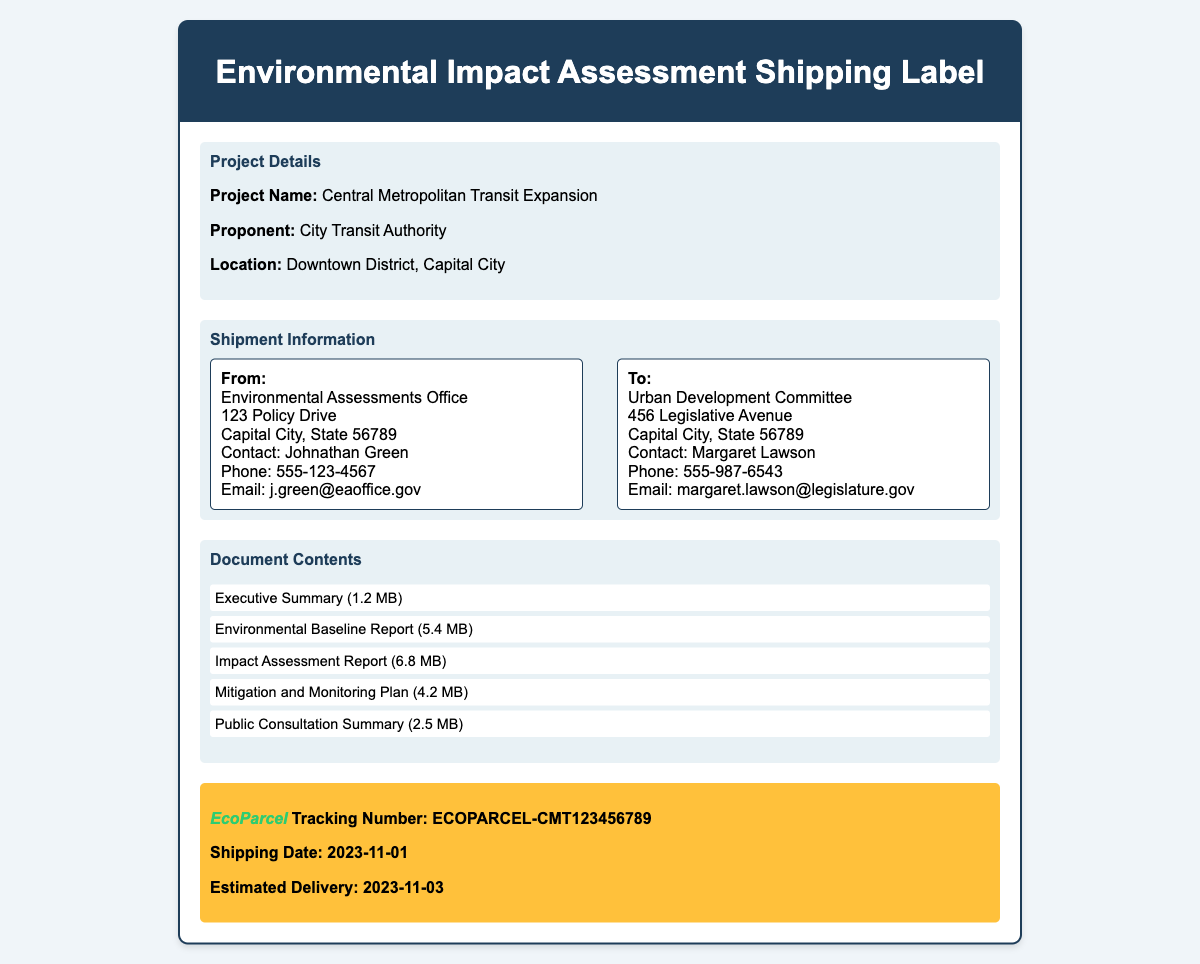What is the project name? The project name is listed as the title in the document details section.
Answer: Central Metropolitan Transit Expansion Who is the proponent of the project? The proponent's name is mentioned in the project details section.
Answer: City Transit Authority What is the estimated delivery date? The estimated delivery date is included in the shipping details section.
Answer: 2023-11-03 How many documents are listed? The total number of documents can be counted from the document contents section.
Answer: 5 What is the size of the Impact Assessment Report? The size of the specific document is stated in the list of document contents.
Answer: 6.8 MB What is the name of the contact person from the Environmental Assessments Office? The contact person is listed in the address box for the sender.
Answer: Johnathan Green What are the shipping details highlighted in the label? The shipping details include the tracking number and shipping date found in the shipping details section.
Answer: ECOPARCEL-CMT123456789 What is the main purpose of this document? The purpose relates to the nature of the contents and title, regarding the assessment of environmental impacts.
Answer: Shipping Label for Environmental Impact Assessment Documents Who should receive these documents? The recipient's details are provided in the address box for the receiver.
Answer: Urban Development Committee 